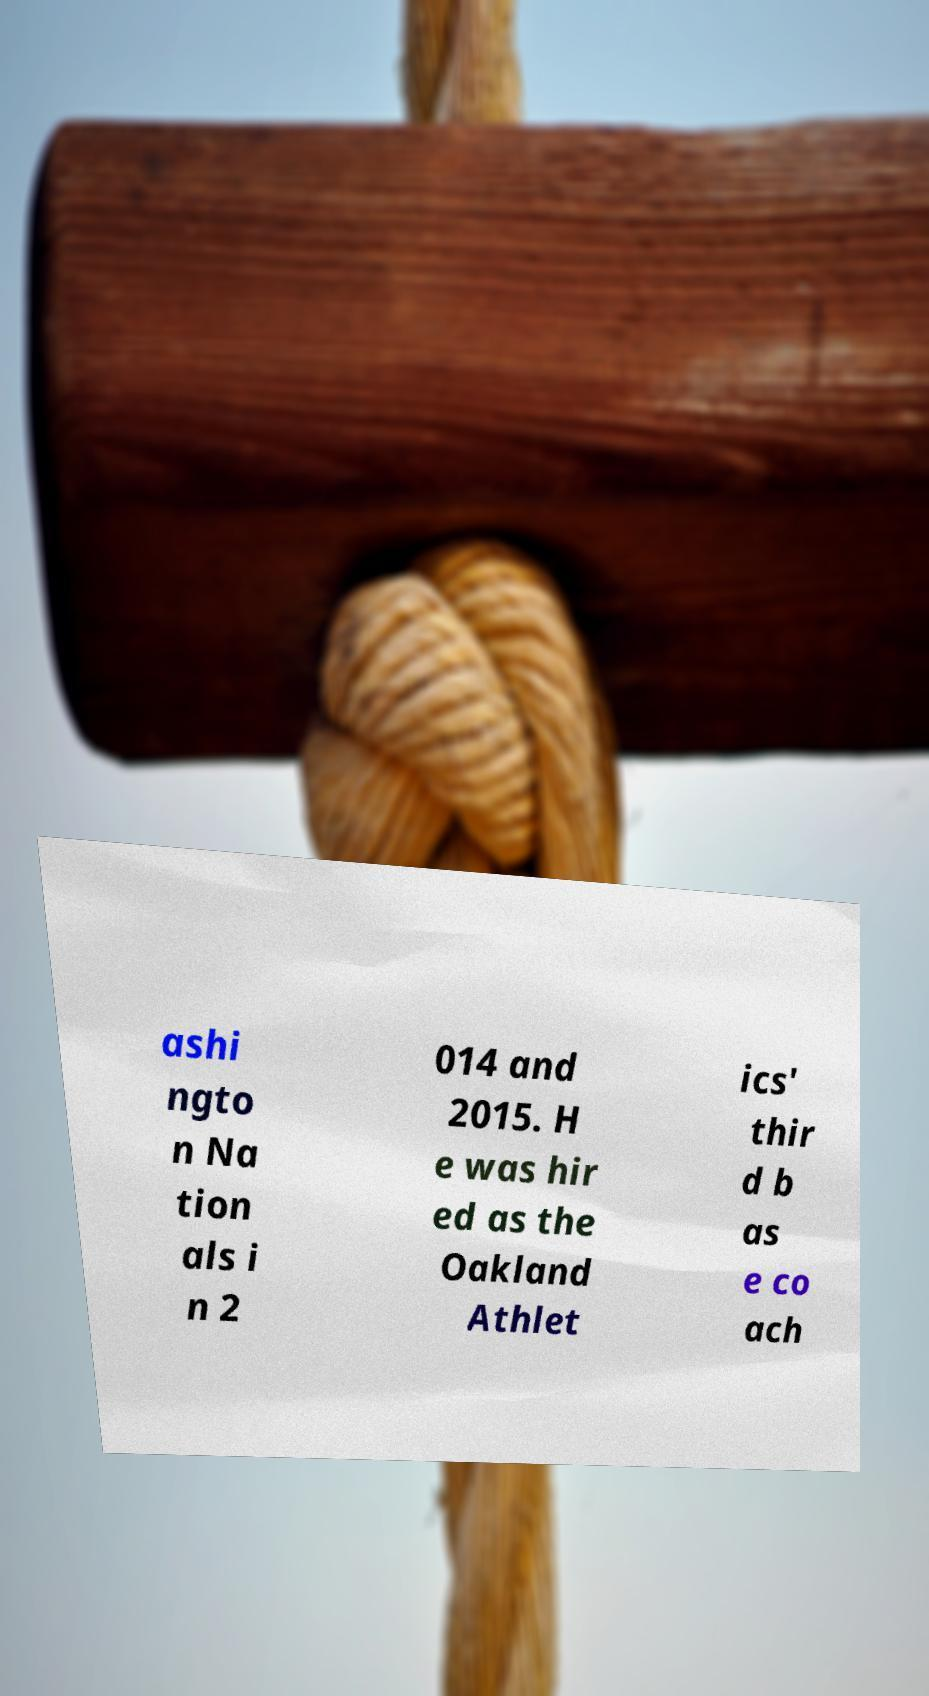Can you read and provide the text displayed in the image?This photo seems to have some interesting text. Can you extract and type it out for me? ashi ngto n Na tion als i n 2 014 and 2015. H e was hir ed as the Oakland Athlet ics' thir d b as e co ach 